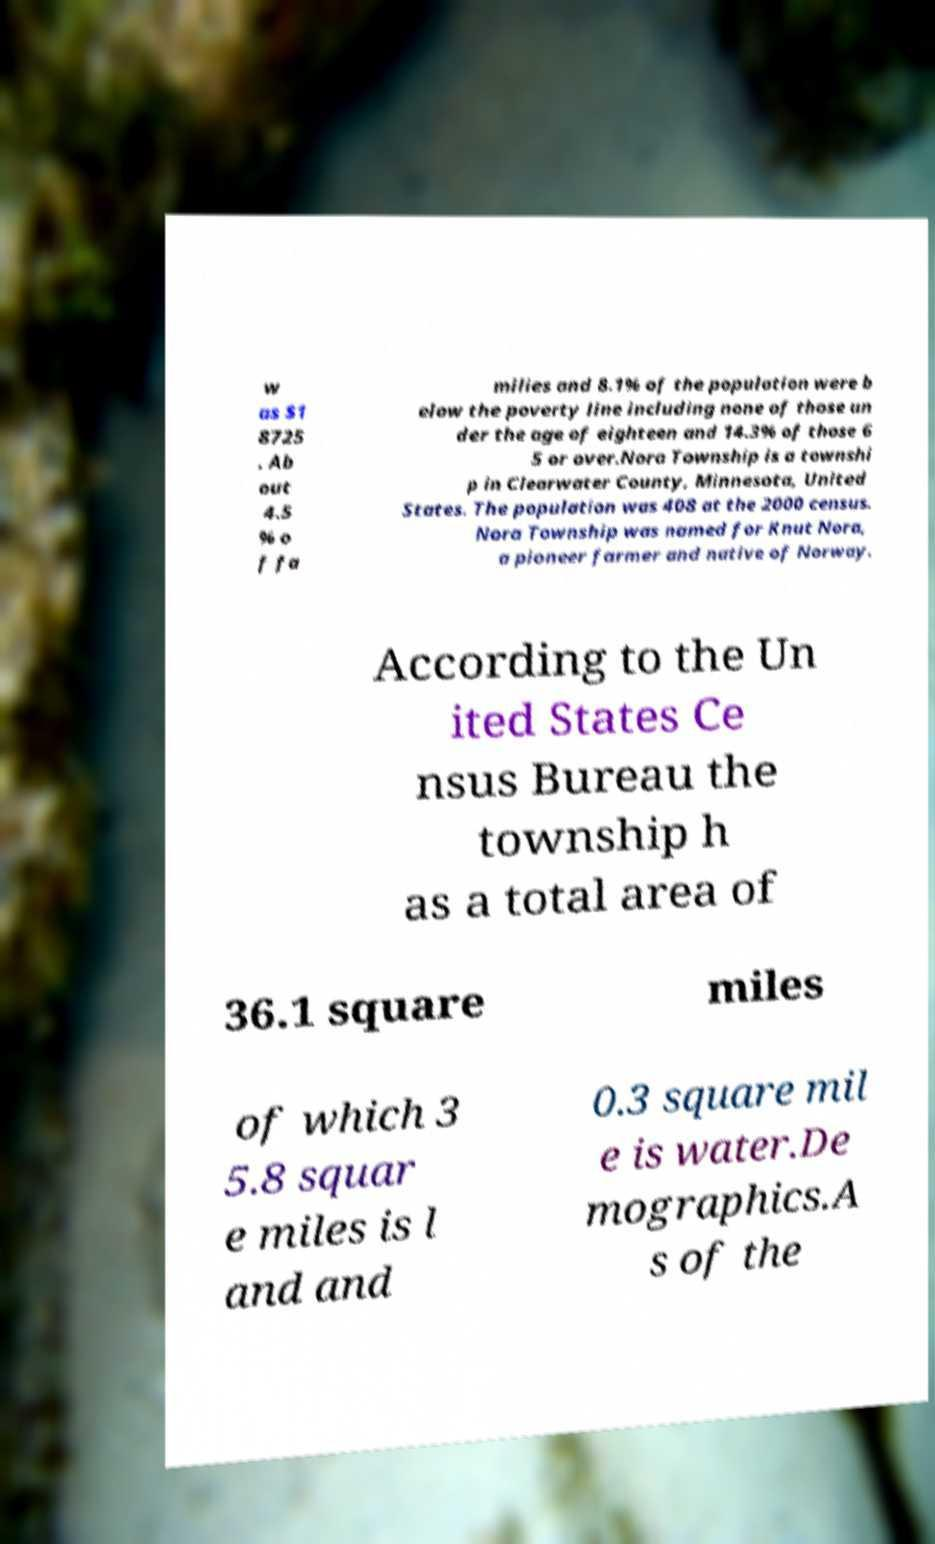I need the written content from this picture converted into text. Can you do that? w as $1 8725 . Ab out 4.5 % o f fa milies and 8.1% of the population were b elow the poverty line including none of those un der the age of eighteen and 14.3% of those 6 5 or over.Nora Township is a townshi p in Clearwater County, Minnesota, United States. The population was 408 at the 2000 census. Nora Township was named for Knut Nora, a pioneer farmer and native of Norway. According to the Un ited States Ce nsus Bureau the township h as a total area of 36.1 square miles of which 3 5.8 squar e miles is l and and 0.3 square mil e is water.De mographics.A s of the 